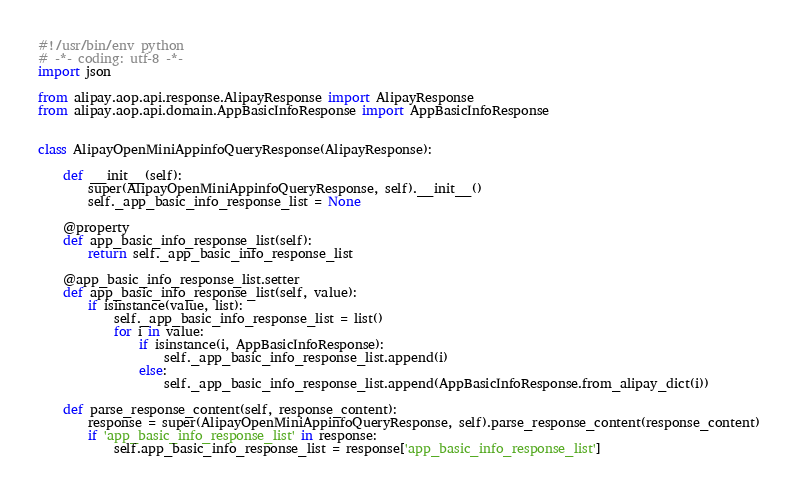<code> <loc_0><loc_0><loc_500><loc_500><_Python_>#!/usr/bin/env python
# -*- coding: utf-8 -*-
import json

from alipay.aop.api.response.AlipayResponse import AlipayResponse
from alipay.aop.api.domain.AppBasicInfoResponse import AppBasicInfoResponse


class AlipayOpenMiniAppinfoQueryResponse(AlipayResponse):

    def __init__(self):
        super(AlipayOpenMiniAppinfoQueryResponse, self).__init__()
        self._app_basic_info_response_list = None

    @property
    def app_basic_info_response_list(self):
        return self._app_basic_info_response_list

    @app_basic_info_response_list.setter
    def app_basic_info_response_list(self, value):
        if isinstance(value, list):
            self._app_basic_info_response_list = list()
            for i in value:
                if isinstance(i, AppBasicInfoResponse):
                    self._app_basic_info_response_list.append(i)
                else:
                    self._app_basic_info_response_list.append(AppBasicInfoResponse.from_alipay_dict(i))

    def parse_response_content(self, response_content):
        response = super(AlipayOpenMiniAppinfoQueryResponse, self).parse_response_content(response_content)
        if 'app_basic_info_response_list' in response:
            self.app_basic_info_response_list = response['app_basic_info_response_list']
</code> 